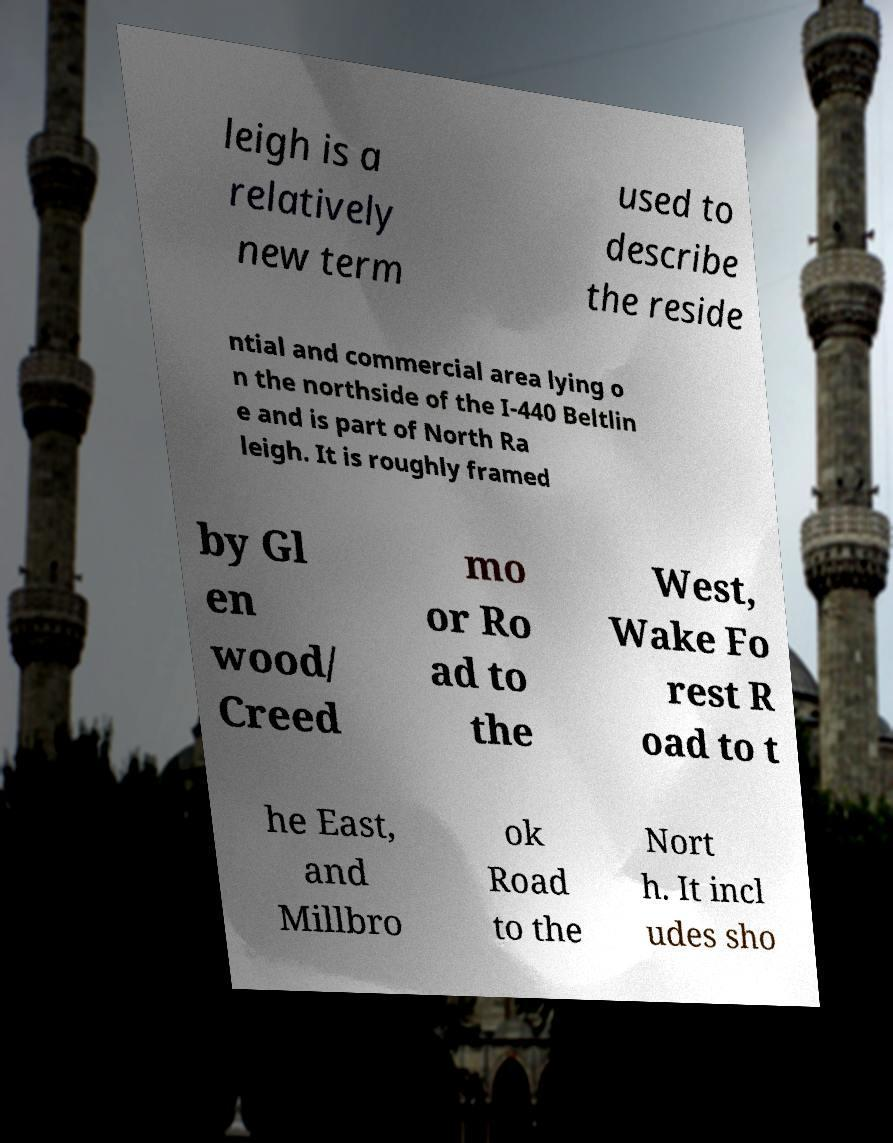What messages or text are displayed in this image? I need them in a readable, typed format. leigh is a relatively new term used to describe the reside ntial and commercial area lying o n the northside of the I-440 Beltlin e and is part of North Ra leigh. It is roughly framed by Gl en wood/ Creed mo or Ro ad to the West, Wake Fo rest R oad to t he East, and Millbro ok Road to the Nort h. It incl udes sho 